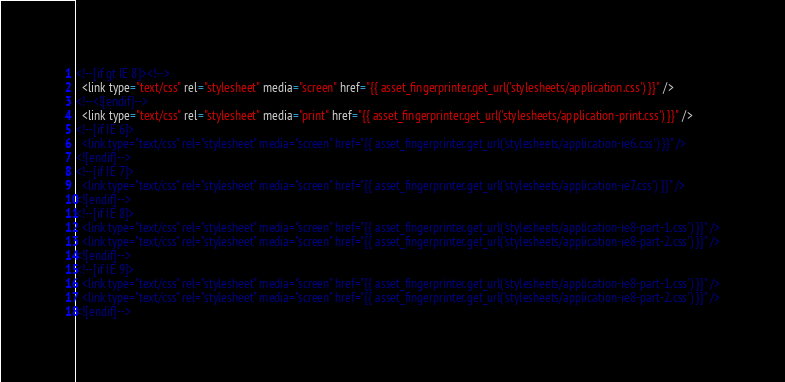Convert code to text. <code><loc_0><loc_0><loc_500><loc_500><_HTML_><!--[if gt IE 8]><!-->
  <link type="text/css" rel="stylesheet" media="screen" href="{{ asset_fingerprinter.get_url('stylesheets/application.css') }}" />
<!--<![endif]-->
  <link type="text/css" rel="stylesheet" media="print" href="{{ asset_fingerprinter.get_url('stylesheets/application-print.css') }}" />
<!--[if IE 6]>
  <link type="text/css" rel="stylesheet" media="screen" href="{{ asset_fingerprinter.get_url('stylesheets/application-ie6.css') }}" />
<![endif]-->
<!--[if IE 7]>
  <link type="text/css" rel="stylesheet" media="screen" href="{{ asset_fingerprinter.get_url('stylesheets/application-ie7.css') }}" />
<![endif]-->
<!--[if IE 8]>
  <link type="text/css" rel="stylesheet" media="screen" href="{{ asset_fingerprinter.get_url('stylesheets/application-ie8-part-1.css') }}" />
  <link type="text/css" rel="stylesheet" media="screen" href="{{ asset_fingerprinter.get_url('stylesheets/application-ie8-part-2.css') }}" />
<![endif]-->
<!--[if IE 9]>
  <link type="text/css" rel="stylesheet" media="screen" href="{{ asset_fingerprinter.get_url('stylesheets/application-ie8-part-1.css') }}" />
  <link type="text/css" rel="stylesheet" media="screen" href="{{ asset_fingerprinter.get_url('stylesheets/application-ie8-part-2.css') }}" />
<![endif]-->
</code> 